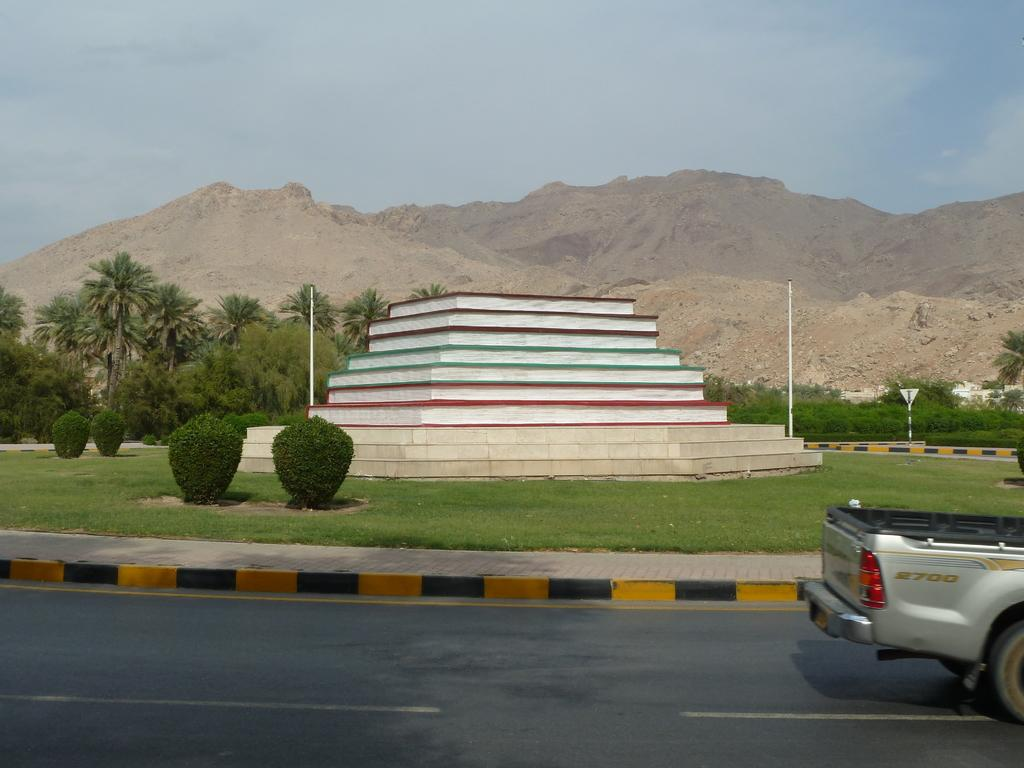What type of natural elements can be seen in the image? There are trees and plants in the image. What type of landscape feature is present in the image? There are hills in the image. Can you describe the structure between the poles? There is an architecture in between poles in the image. What mode of transportation can be seen in the image? There is a vehicle on the road in the image. What is visible at the top of the image? The sky is visible at the top of the image. What type of vase can be seen on the hill in the image? There is no vase present on the hill in the image. What time of day is it in the image? The time of day cannot be determined from the image alone, as there are no specific indicators of time. 